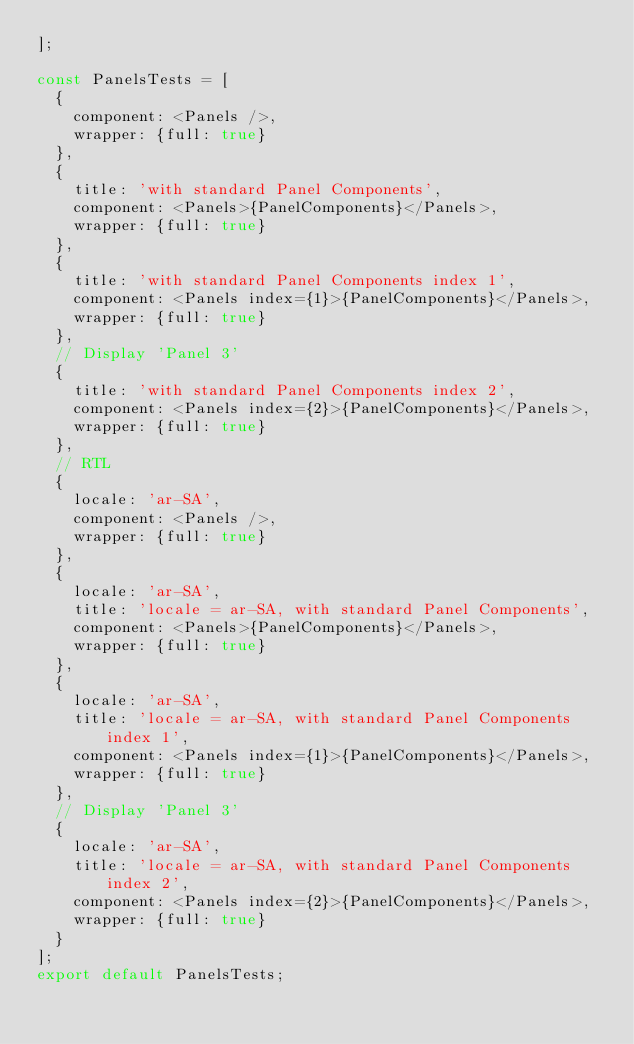<code> <loc_0><loc_0><loc_500><loc_500><_JavaScript_>];

const PanelsTests = [
	{
		component: <Panels />,
		wrapper: {full: true}
	},
	{
		title: 'with standard Panel Components',
		component: <Panels>{PanelComponents}</Panels>,
		wrapper: {full: true}
	},
	{
		title: 'with standard Panel Components index 1',
		component: <Panels index={1}>{PanelComponents}</Panels>,
		wrapper: {full: true}
	},
	// Display 'Panel 3'
	{
		title: 'with standard Panel Components index 2',
		component: <Panels index={2}>{PanelComponents}</Panels>,
		wrapper: {full: true}
	},
	// RTL
	{
		locale: 'ar-SA',
		component: <Panels />,
		wrapper: {full: true}
	},
	{
		locale: 'ar-SA',
		title: 'locale = ar-SA, with standard Panel Components',
		component: <Panels>{PanelComponents}</Panels>,
		wrapper: {full: true}
	},
	{
		locale: 'ar-SA',
		title: 'locale = ar-SA, with standard Panel Components index 1',
		component: <Panels index={1}>{PanelComponents}</Panels>,
		wrapper: {full: true}
	},
	// Display 'Panel 3'
	{
		locale: 'ar-SA',
		title: 'locale = ar-SA, with standard Panel Components index 2',
		component: <Panels index={2}>{PanelComponents}</Panels>,
		wrapper: {full: true}
	}
];
export default PanelsTests;
</code> 